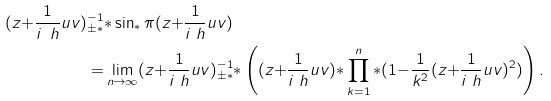Convert formula to latex. <formula><loc_0><loc_0><loc_500><loc_500>( z { + } \frac { 1 } { i \ h } u v ) _ { \pm * } ^ { - 1 } & { * } \sin _ { * } \pi ( z { + } \frac { 1 } { i \ h } u v ) \\ { = } & \lim _ { n \to \infty } ( z { + } \frac { 1 } { i \ h } u v ) _ { \pm * } ^ { - 1 } { * } \left ( ( z { + } \frac { 1 } { i \ h } u v ) { * } \prod ^ { n } _ { k = 1 } { * } ( 1 { - } \frac { 1 } { k ^ { 2 } } ( z { + } \frac { 1 } { i \ h } u v ) ^ { 2 } ) \right ) .</formula> 